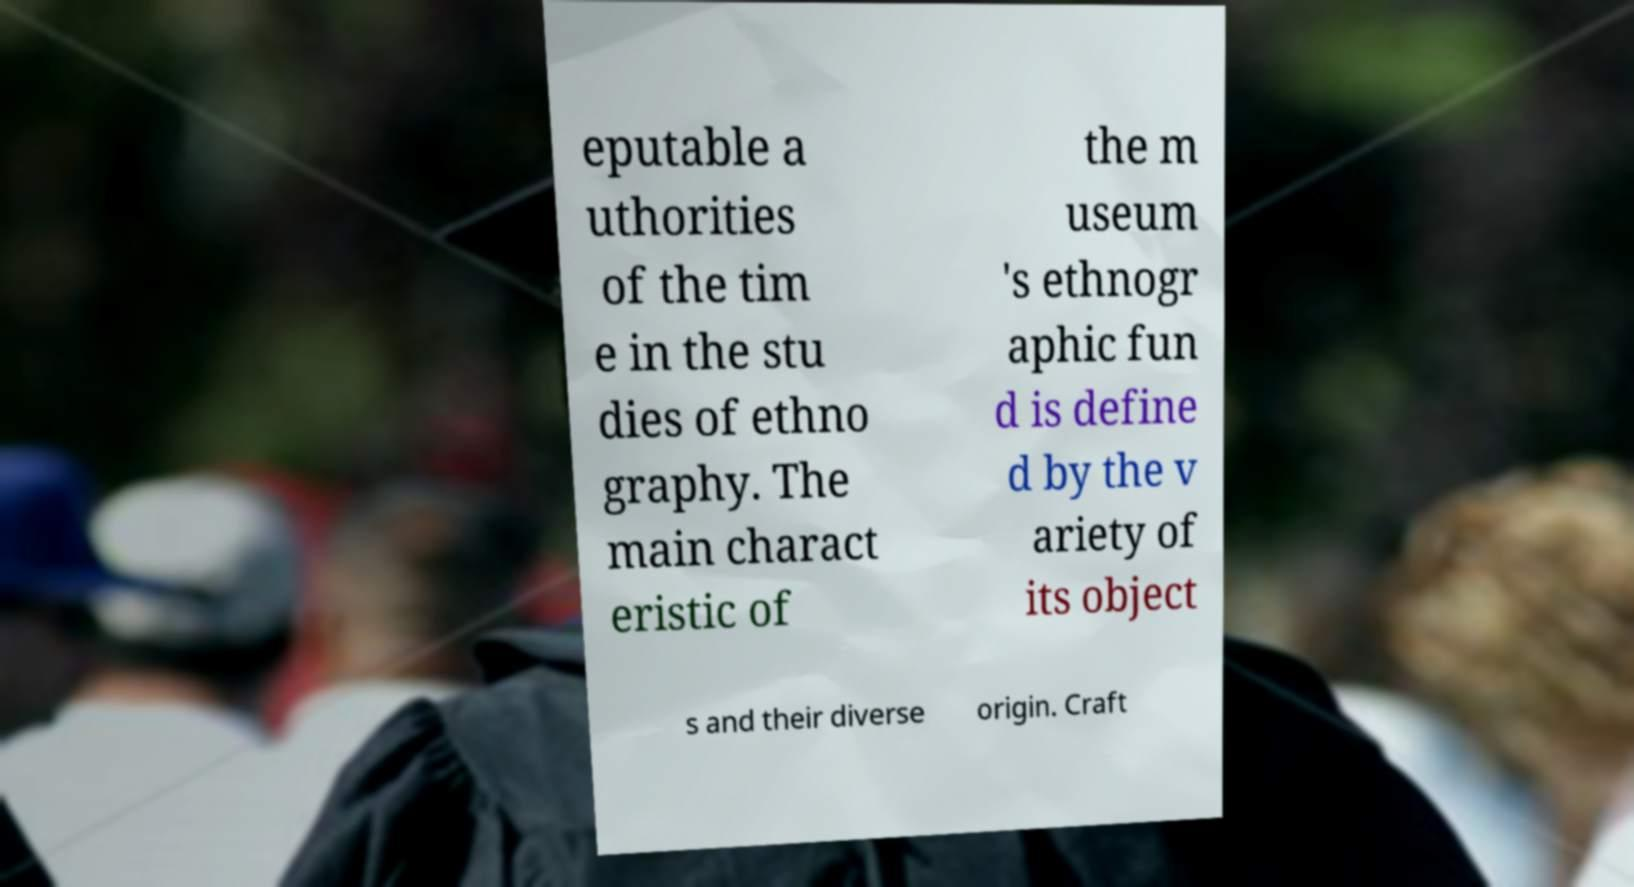Can you accurately transcribe the text from the provided image for me? eputable a uthorities of the tim e in the stu dies of ethno graphy. The main charact eristic of the m useum 's ethnogr aphic fun d is define d by the v ariety of its object s and their diverse origin. Craft 